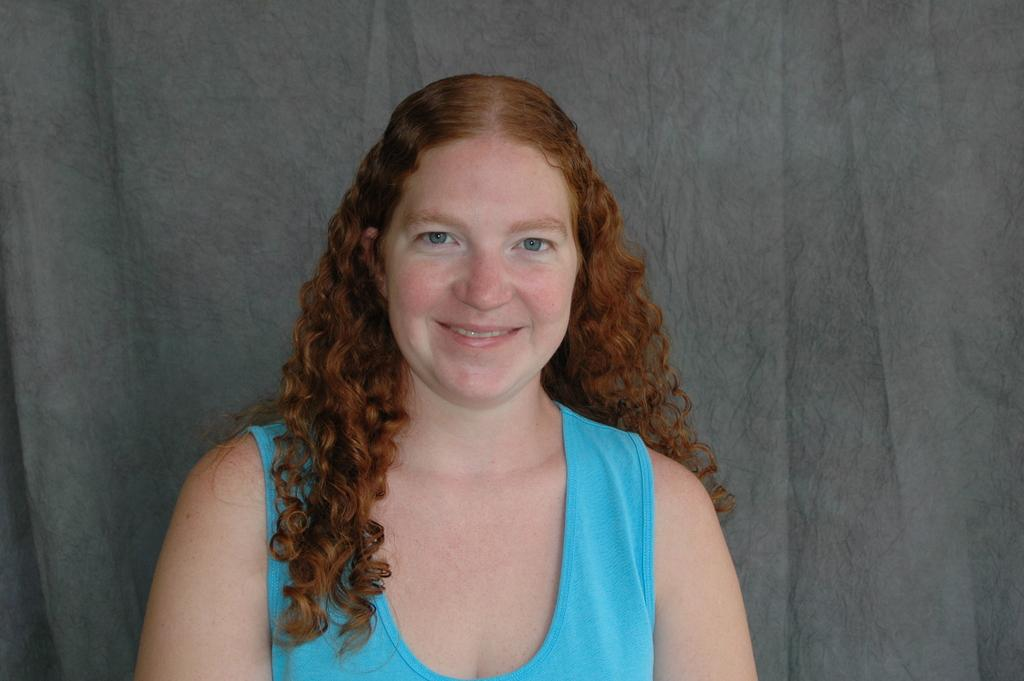Who is present in the image? There is a woman in the image. What expression does the woman have? The woman is smiling. What can be seen in the background of the image? There is a curtain in the background of the image. What type of fork is the woman holding in the image? There is no fork present in the image; the woman is not holding anything. 